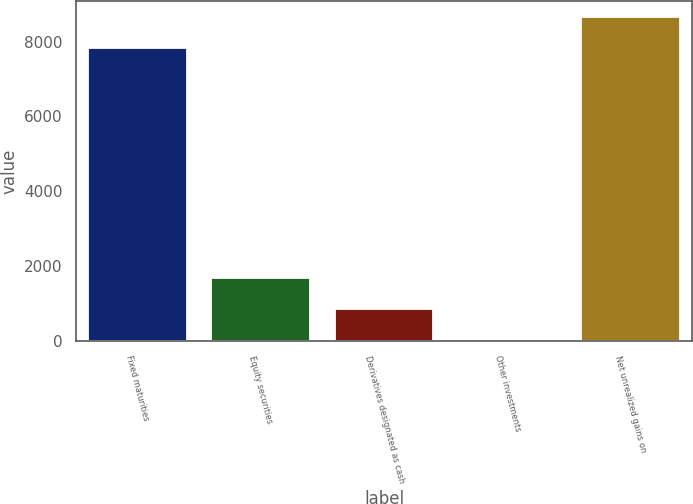<chart> <loc_0><loc_0><loc_500><loc_500><bar_chart><fcel>Fixed maturities<fcel>Equity securities<fcel>Derivatives designated as cash<fcel>Other investments<fcel>Net unrealized gains on<nl><fcel>7816<fcel>1689<fcel>854.5<fcel>20<fcel>8650.5<nl></chart> 